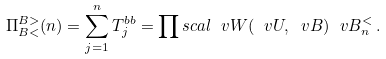Convert formula to latex. <formula><loc_0><loc_0><loc_500><loc_500>\Pi ^ { B > } _ { B < } ( n ) = \sum _ { j = 1 } ^ { n } T ^ { b b } _ { j } = \prod s c a l { \ v W ( \ v U , \ v B ) } { \ v B ^ { < } _ { n } } \, .</formula> 